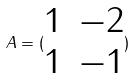<formula> <loc_0><loc_0><loc_500><loc_500>A = ( \begin{matrix} 1 & - 2 \\ 1 & - 1 \end{matrix} )</formula> 